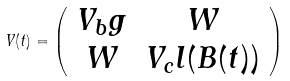Convert formula to latex. <formula><loc_0><loc_0><loc_500><loc_500>V ( t ) = \left ( \begin{array} { c c } V _ { b } g & W \\ W & V _ { c } l ( B ( t ) ) \end{array} \right )</formula> 